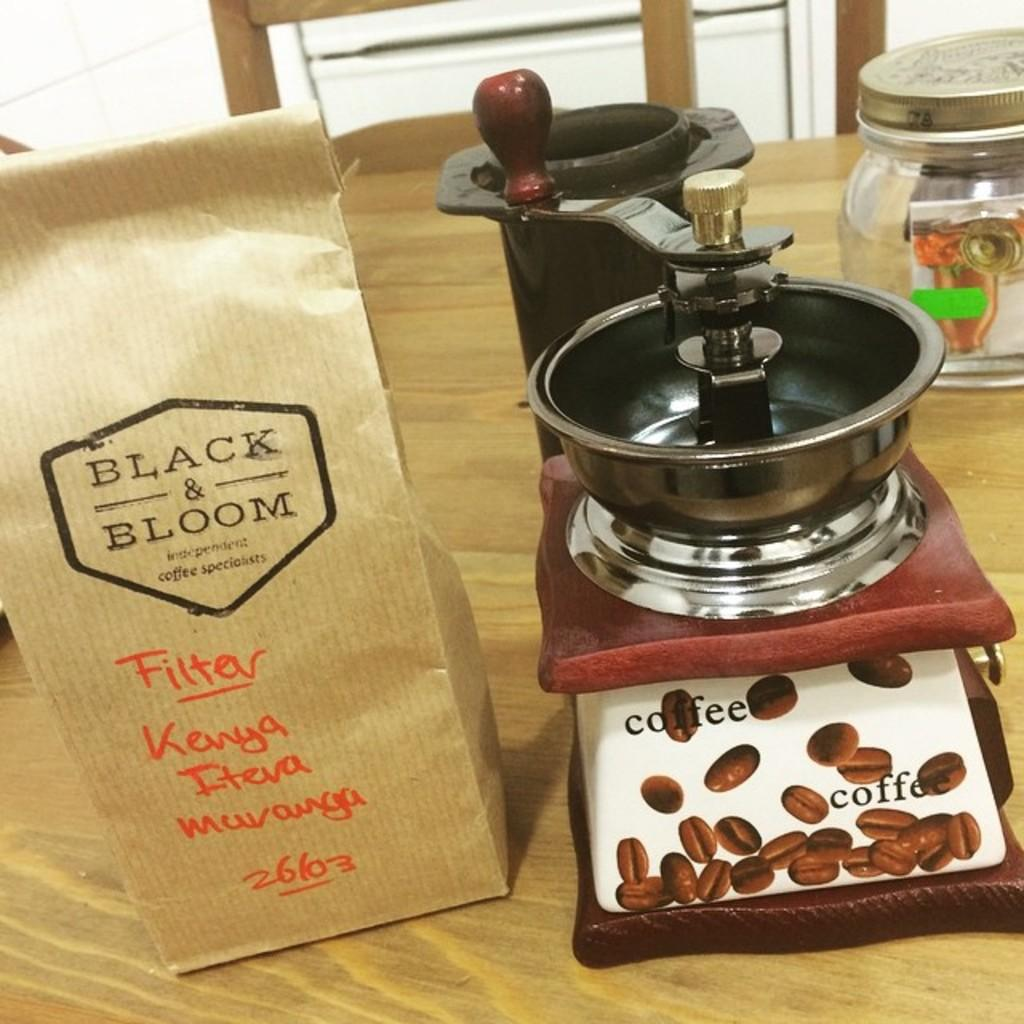Provide a one-sentence caption for the provided image. A bag from Black and Bloom coffee specialists has been labeled "Filter" and "Kenya". 